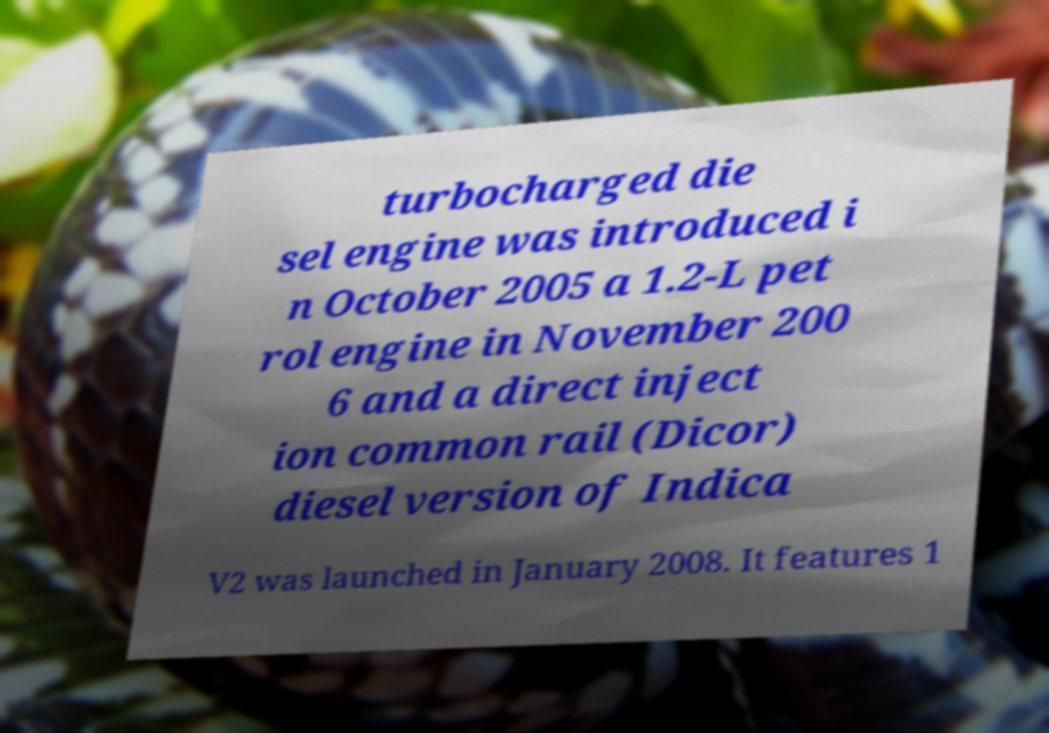Please identify and transcribe the text found in this image. turbocharged die sel engine was introduced i n October 2005 a 1.2-L pet rol engine in November 200 6 and a direct inject ion common rail (Dicor) diesel version of Indica V2 was launched in January 2008. It features 1 